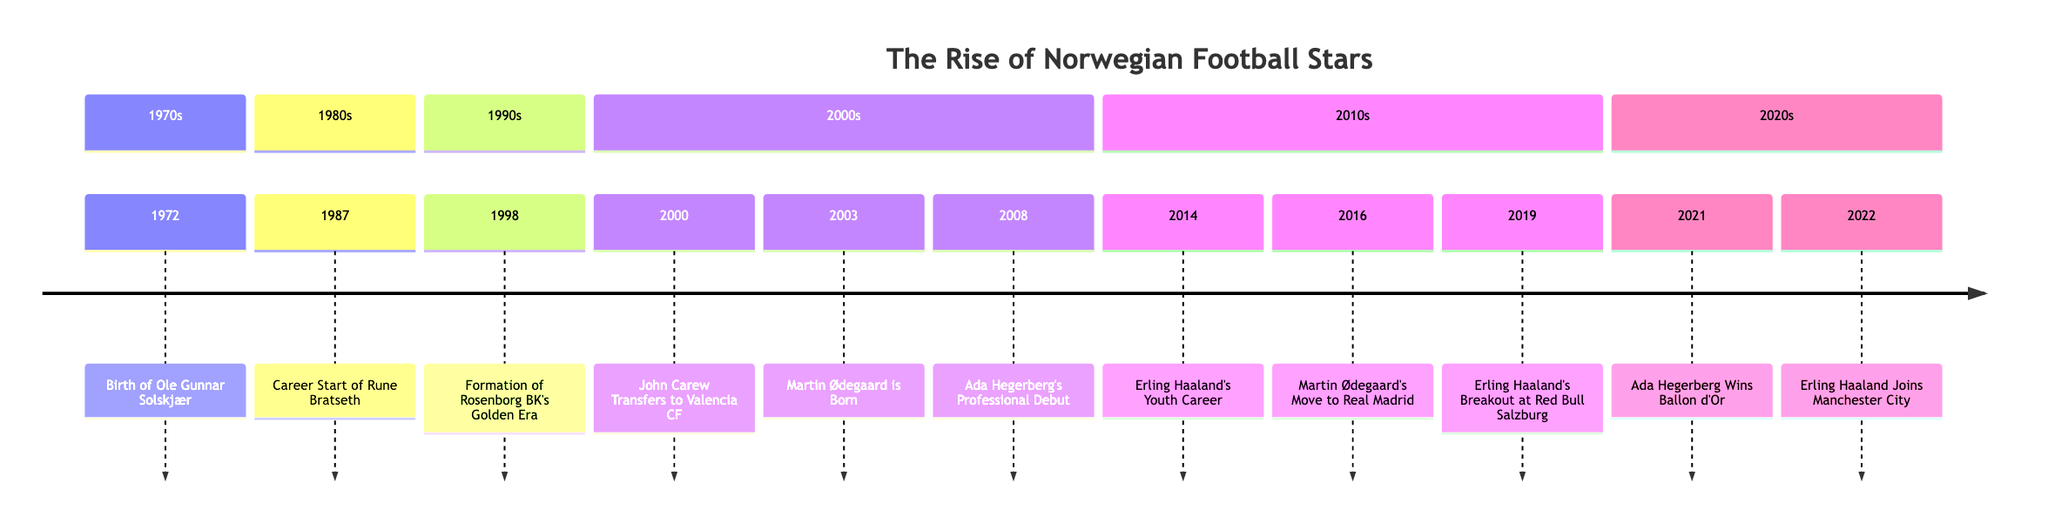What year was Ole Gunnar Solskjær born? The timeline shows "Birth of Ole Gunnar Solskjær" happening in the year 1972. Therefore, the specific year of his birth is directly taken from that entry.
Answer: 1972 Which Norwegian footballer had their professional debut in 2008? The entry for the year 2008 states "Ada Hegerberg's Professional Debut". This indicates that Ada Hegerberg made her debut that year.
Answer: Ada Hegerberg In what year did Erling Haaland join Manchester City? The timeline shows that Erling Haaland transferred to Manchester City in the year 2022, as represented by the entry. By locating the relevant event, we can determine the answer.
Answer: 2022 What event occurred in 2016? The event listed for the year 2016 is "Martin Ødegaard's Move to Real Madrid", which highlights the significant transfer for Ødegaard. Thus, the primary event for that year is identified from the timeline.
Answer: Martin Ødegaard's Move to Real Madrid How many events are listed in the 1990s section? By counting the number of events in the 1990s section of the timeline, we find there is only one event, "Formation of Rosenborg BK's Golden Era", specifically noted in that decade.
Answer: 1 Which player scored 9 goals in a U-20 World Cup match? The timeline entry for 2019 indicates that "Erling Haaland's Breakout at Red Bull Salzburg" includes scoring 9 goals in a single U-20 World Cup match, providing an insight into his remarkable achievement during that year.
Answer: Erling Haaland What significant achievement did Ada Hegerberg accomplish in 2021? The timeline indicates that in 2021, "Ada Hegerberg Wins Ballon d'Or". This significant achievement highlights her prominence in women’s football and marks a historical moment. Therefore, we can directly refer to that entry for the answer.
Answer: Ballon d'Or Who began their career with Rosenborg BK? The entry for 1987 states "Career Start of Rune Bratseth", identifying him as the player who began his professional career there. This allows easy identification of the answer through direct reference to the timeline detail.
Answer: Rune Bratseth What key achievement did Rosenborg BK accomplish between 1992 and 2004? The timeline states that during the formation of Rosenborg BK's Golden Era, they won the league 13 consecutive times from 1992 to 2004. Hence, this specific achievement can be derived from that entry.
Answer: 13 consecutive times 